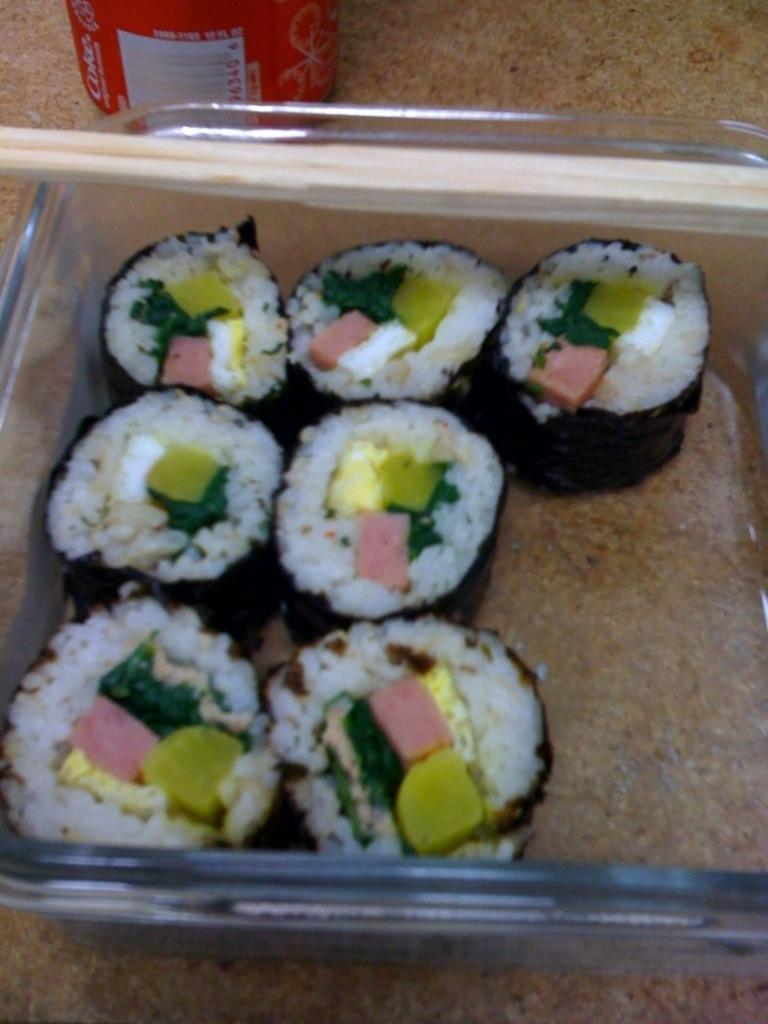What is in the tray that is visible in the image? There is food in the tray in the image. What else can be seen in the background of the image? There is a bottle in the background of the image. What is the main piece of furniture in the image? There is a table at the bottom of the image. What type of copper material can be seen in the image? There is no copper material present in the image. How do the cars stop in the image? There are no cars present in the image. 